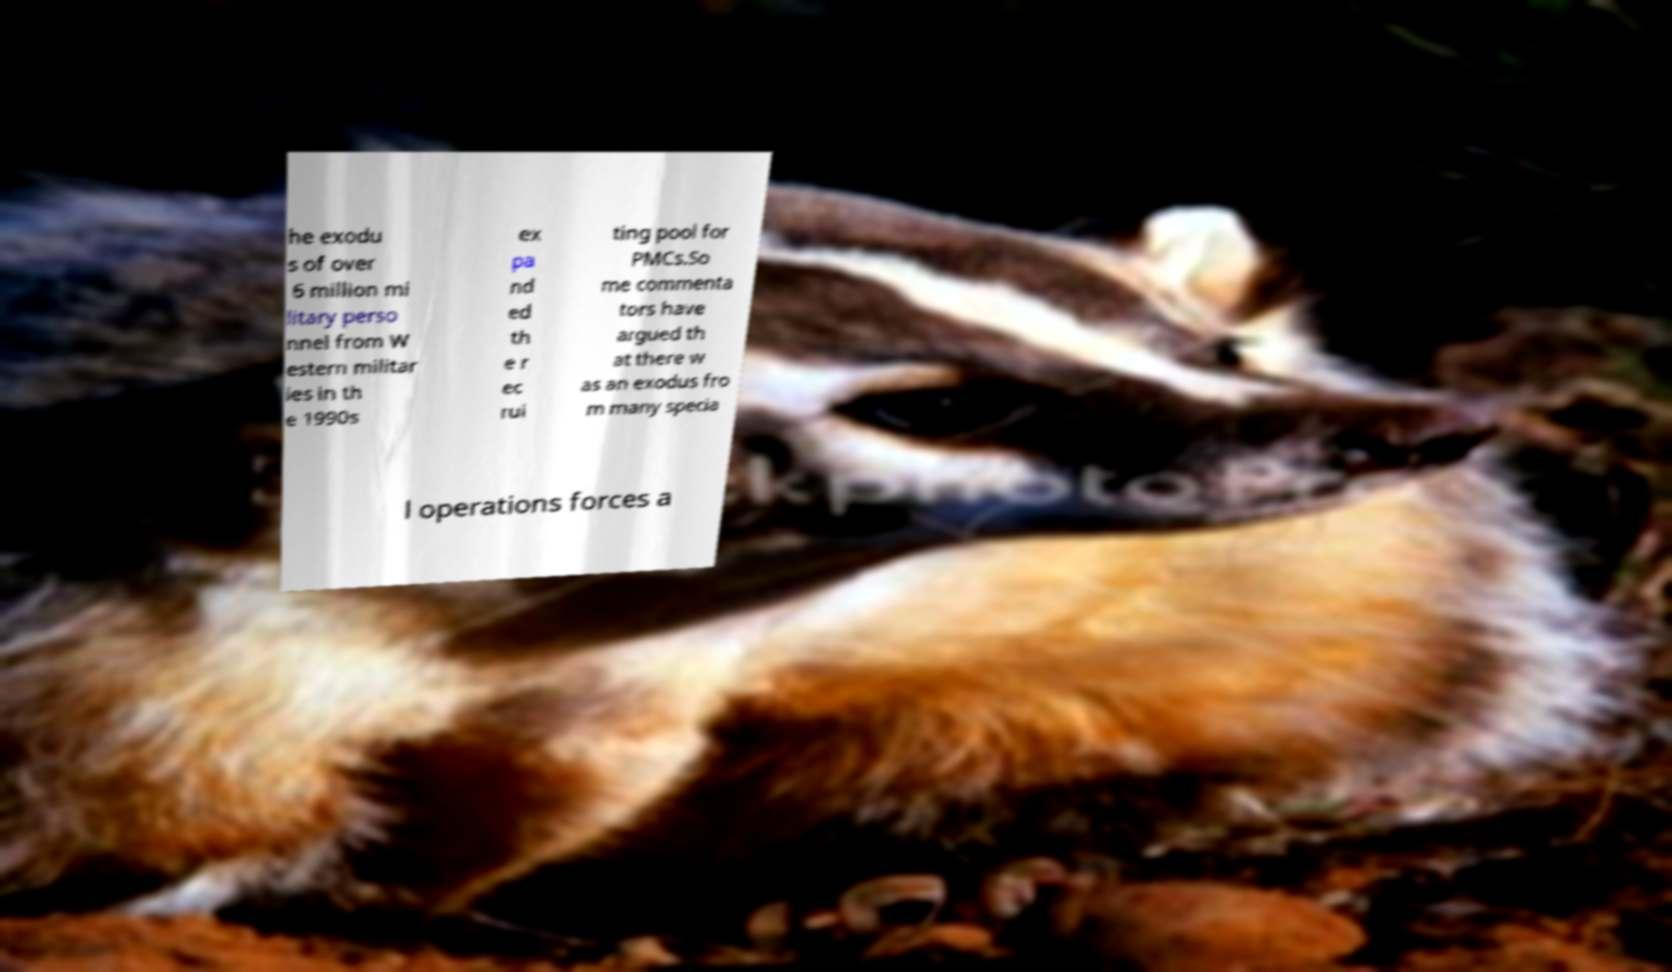What messages or text are displayed in this image? I need them in a readable, typed format. he exodu s of over 6 million mi litary perso nnel from W estern militar ies in th e 1990s ex pa nd ed th e r ec rui ting pool for PMCs.So me commenta tors have argued th at there w as an exodus fro m many specia l operations forces a 